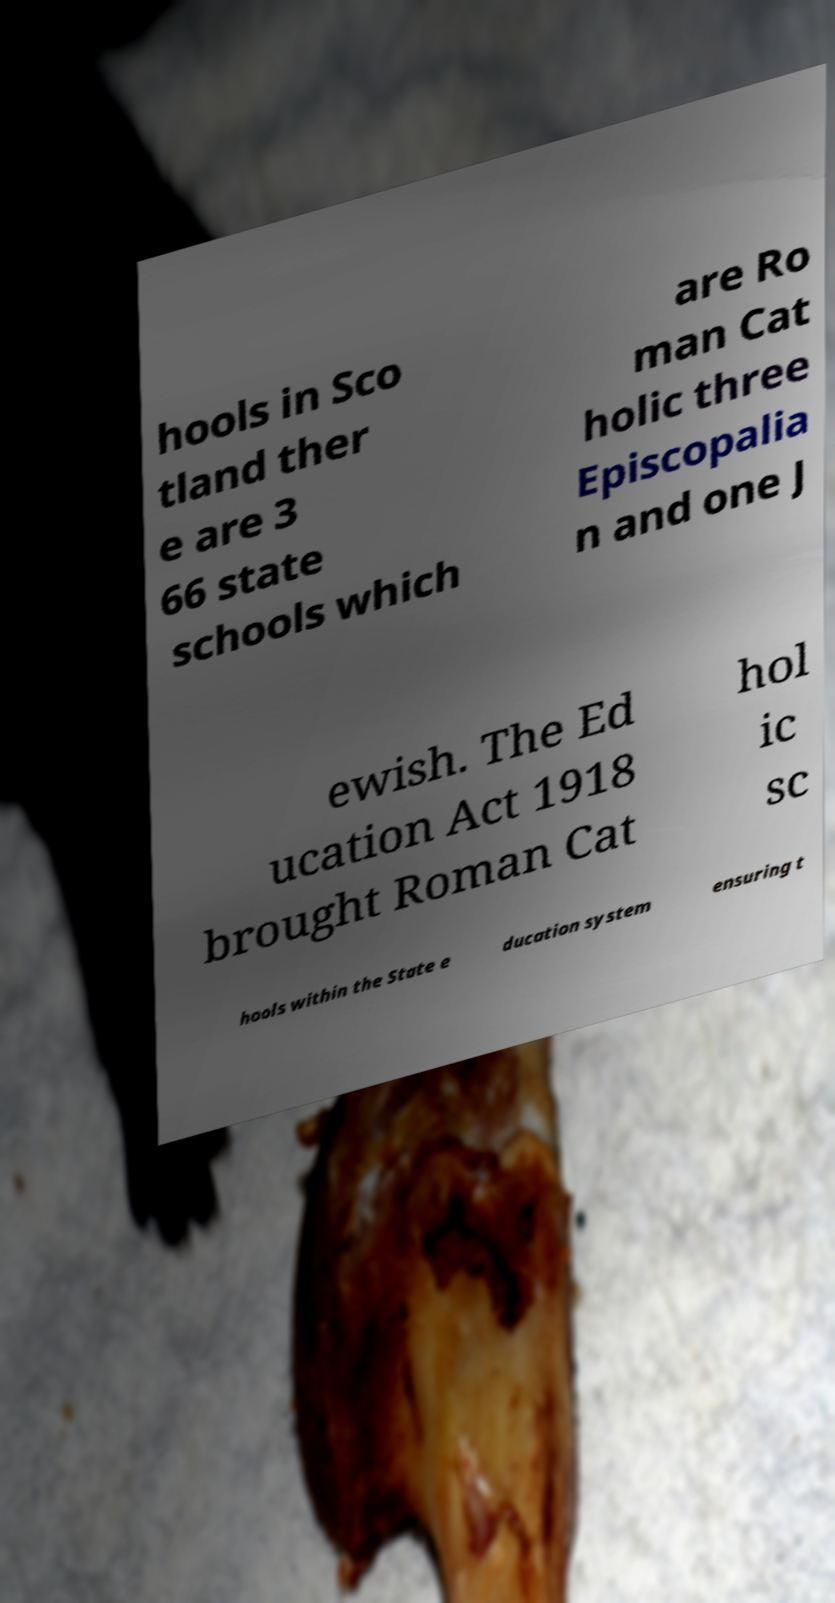There's text embedded in this image that I need extracted. Can you transcribe it verbatim? hools in Sco tland ther e are 3 66 state schools which are Ro man Cat holic three Episcopalia n and one J ewish. The Ed ucation Act 1918 brought Roman Cat hol ic sc hools within the State e ducation system ensuring t 